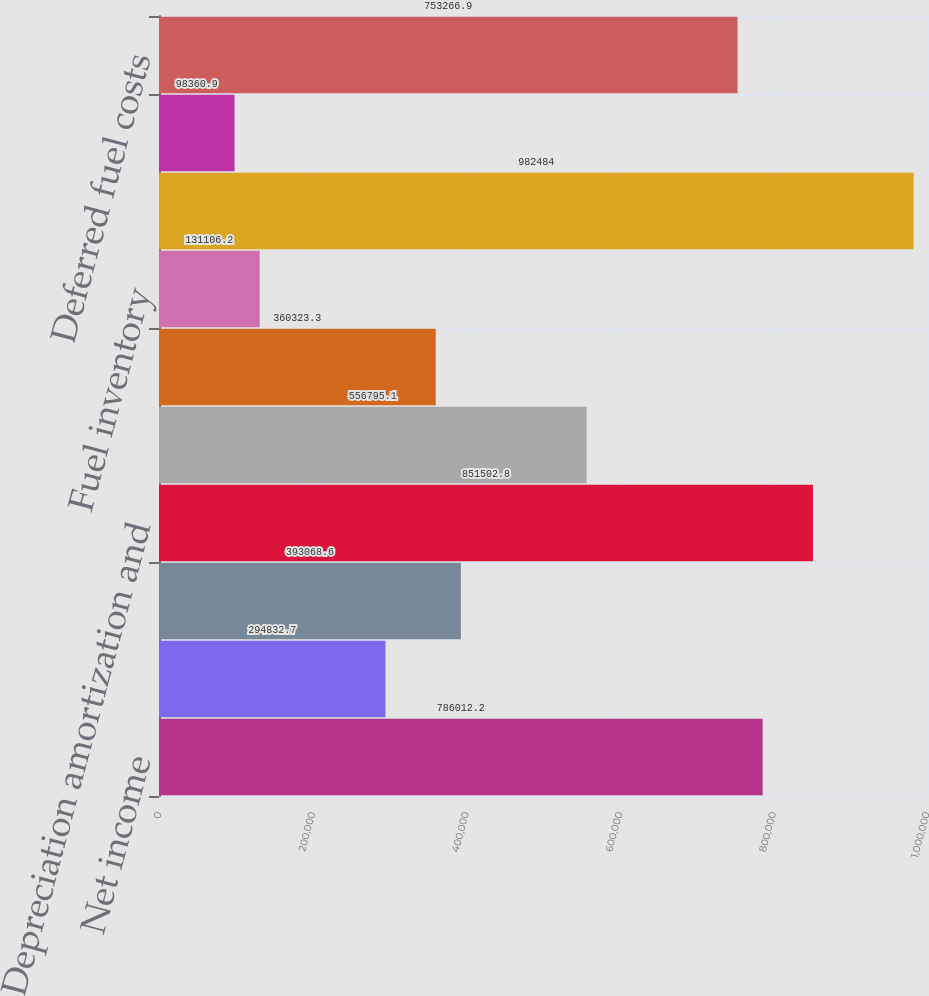Convert chart. <chart><loc_0><loc_0><loc_500><loc_500><bar_chart><fcel>Net income<fcel>Reserve for regulatory<fcel>Other regulatory credits - net<fcel>Depreciation amortization and<fcel>Deferred income taxes<fcel>Receivables<fcel>Fuel inventory<fcel>Accounts payable<fcel>Interest accrued<fcel>Deferred fuel costs<nl><fcel>786012<fcel>294833<fcel>393069<fcel>851503<fcel>556795<fcel>360323<fcel>131106<fcel>982484<fcel>98360.9<fcel>753267<nl></chart> 